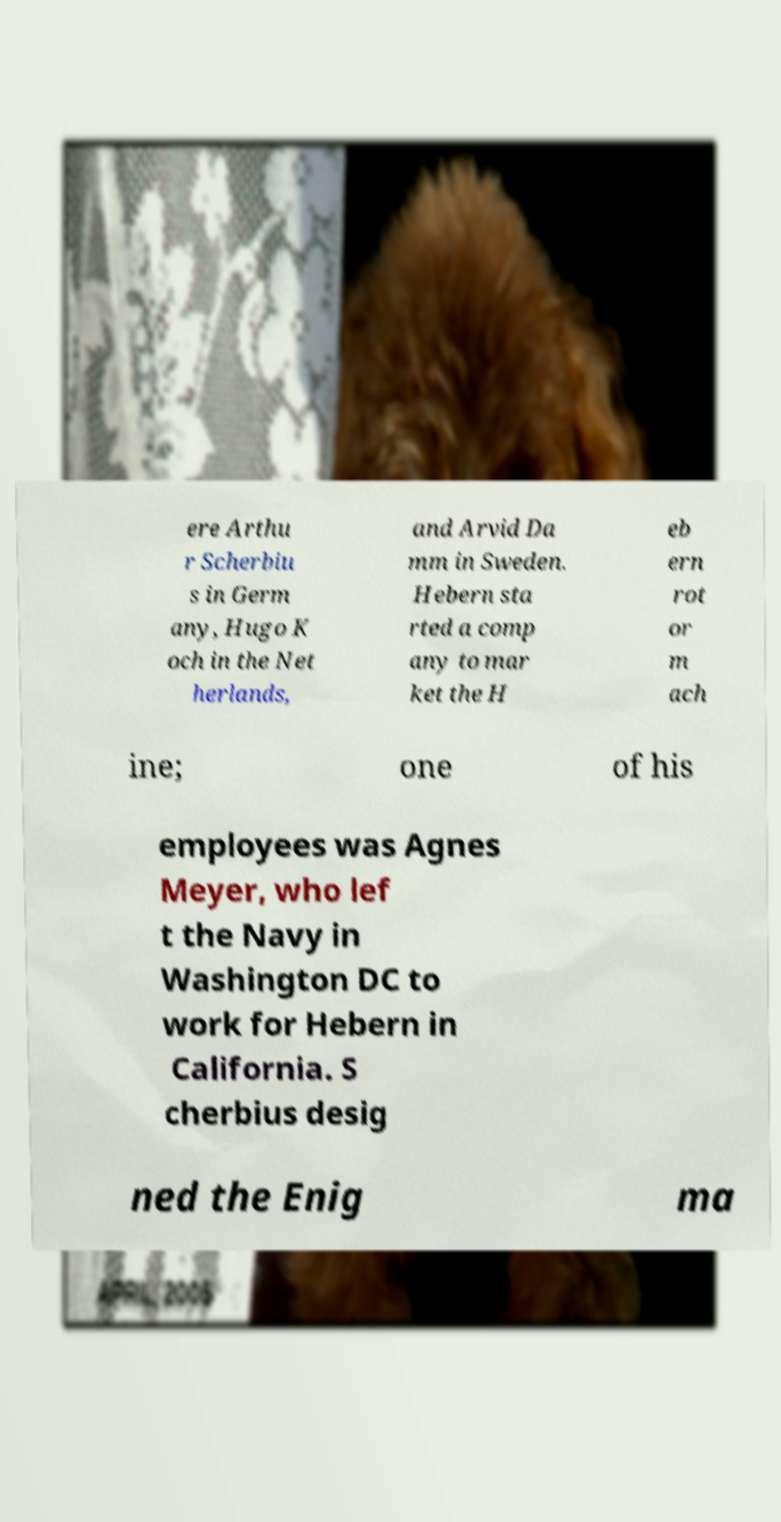For documentation purposes, I need the text within this image transcribed. Could you provide that? ere Arthu r Scherbiu s in Germ any, Hugo K och in the Net herlands, and Arvid Da mm in Sweden. Hebern sta rted a comp any to mar ket the H eb ern rot or m ach ine; one of his employees was Agnes Meyer, who lef t the Navy in Washington DC to work for Hebern in California. S cherbius desig ned the Enig ma 